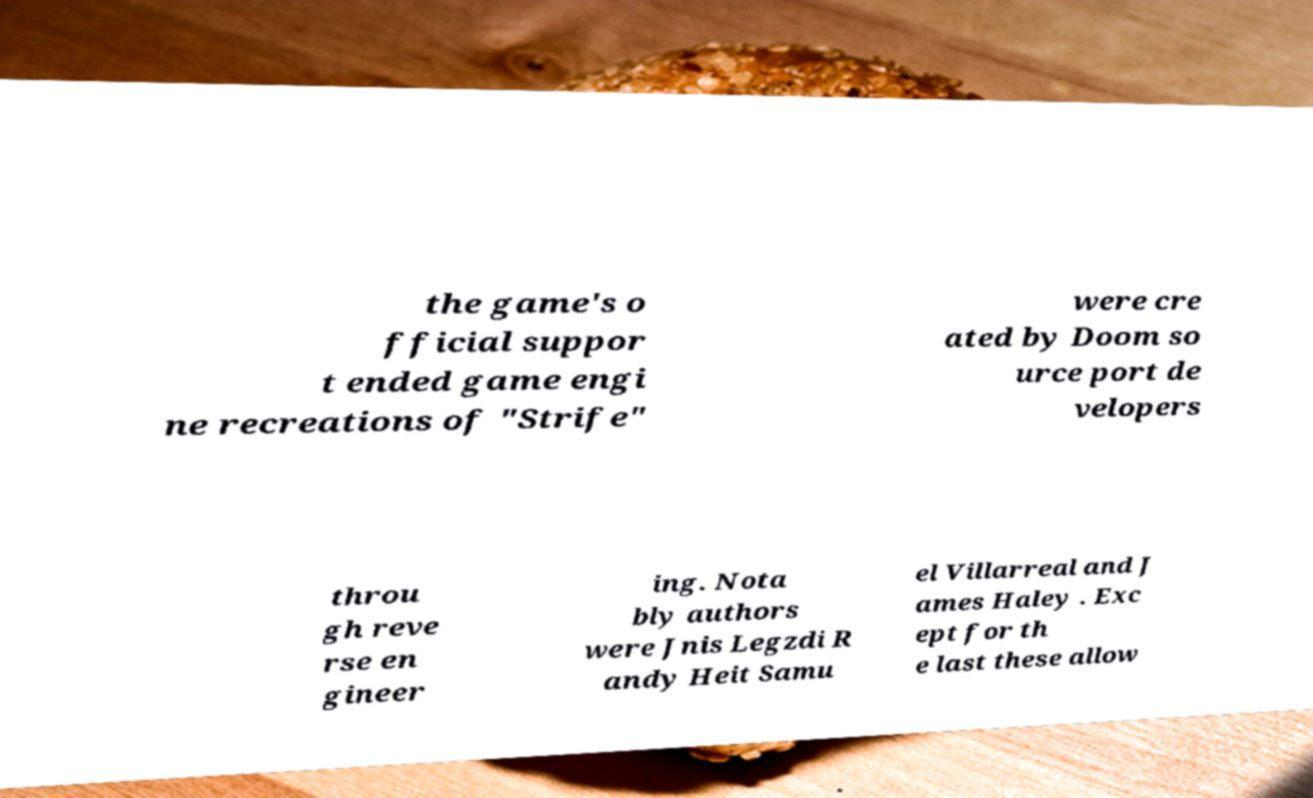What messages or text are displayed in this image? I need them in a readable, typed format. the game's o fficial suppor t ended game engi ne recreations of "Strife" were cre ated by Doom so urce port de velopers throu gh reve rse en gineer ing. Nota bly authors were Jnis Legzdi R andy Heit Samu el Villarreal and J ames Haley . Exc ept for th e last these allow 